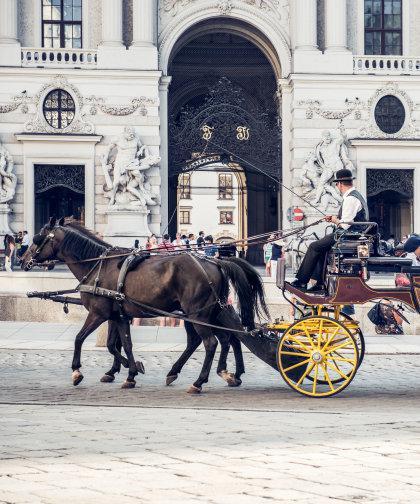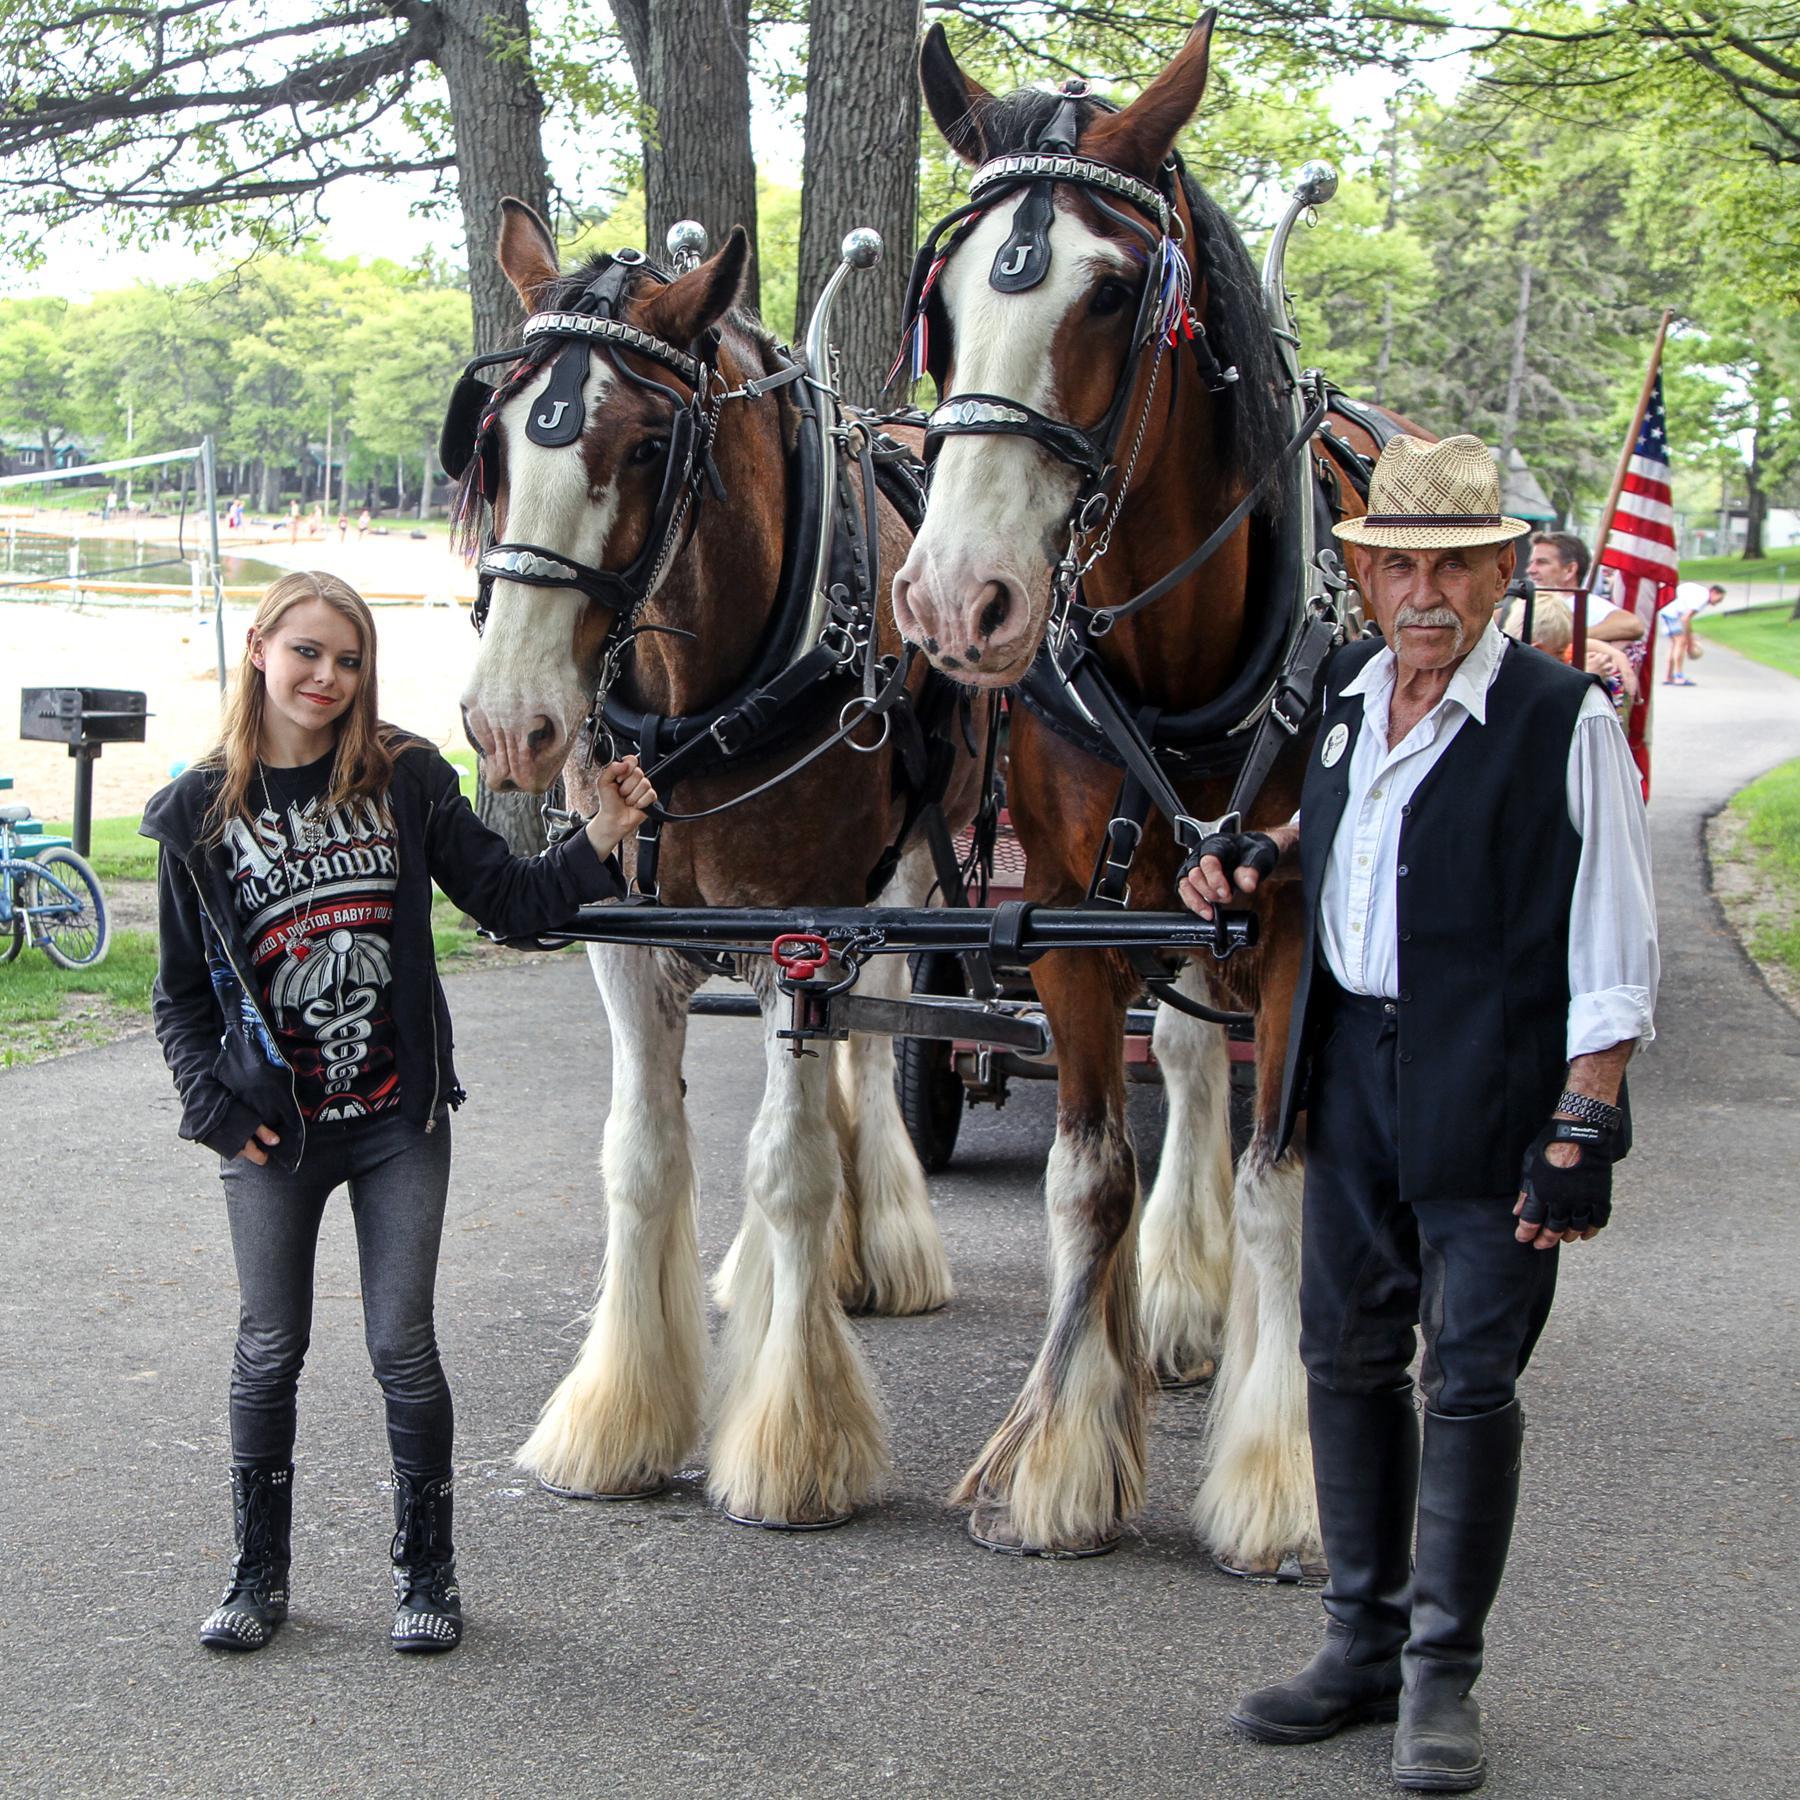The first image is the image on the left, the second image is the image on the right. Examine the images to the left and right. Is the description "In one image, there are a pair of horses drawing a carriage holding one person to the left." accurate? Answer yes or no. Yes. The first image is the image on the left, the second image is the image on the right. Considering the images on both sides, is "At least one of the horses is white." valid? Answer yes or no. No. 